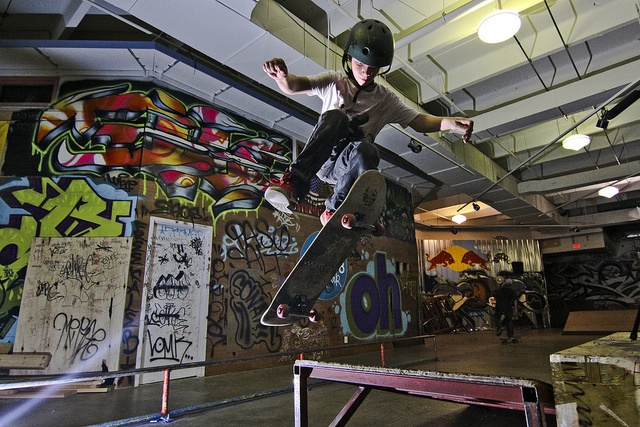Describe the objects in this image and their specific colors. I can see people in purple, black, darkgray, gray, and lavender tones, skateboard in purple, black, gray, and lightgray tones, people in purple, black, and gray tones, and skateboard in black, gray, and purple tones in this image. 